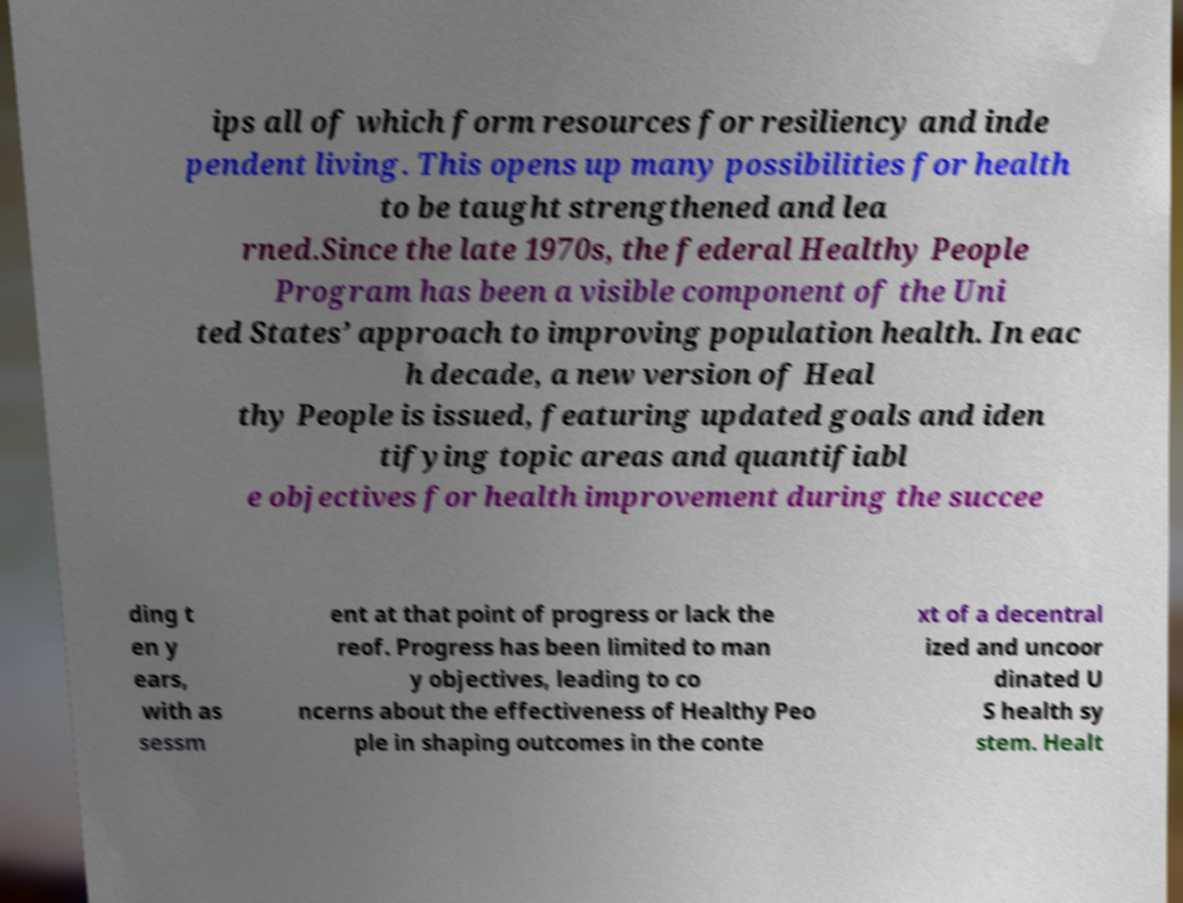For documentation purposes, I need the text within this image transcribed. Could you provide that? ips all of which form resources for resiliency and inde pendent living. This opens up many possibilities for health to be taught strengthened and lea rned.Since the late 1970s, the federal Healthy People Program has been a visible component of the Uni ted States’ approach to improving population health. In eac h decade, a new version of Heal thy People is issued, featuring updated goals and iden tifying topic areas and quantifiabl e objectives for health improvement during the succee ding t en y ears, with as sessm ent at that point of progress or lack the reof. Progress has been limited to man y objectives, leading to co ncerns about the effectiveness of Healthy Peo ple in shaping outcomes in the conte xt of a decentral ized and uncoor dinated U S health sy stem. Healt 